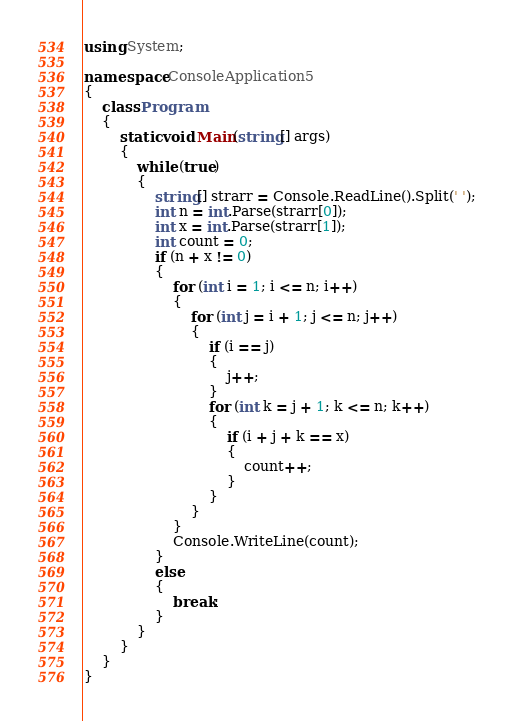Convert code to text. <code><loc_0><loc_0><loc_500><loc_500><_C#_>using System;

namespace ConsoleApplication5
{
    class Program
    {
        static void Main(string[] args)
        {
            while (true)
            {
                string[] strarr = Console.ReadLine().Split(' ');
                int n = int.Parse(strarr[0]);
                int x = int.Parse(strarr[1]);
                int count = 0;
                if (n + x != 0)
                {
                    for (int i = 1; i <= n; i++)
                    {
                        for (int j = i + 1; j <= n; j++)
                        {
                            if (i == j)
                            {
                                j++;
                            }
                            for (int k = j + 1; k <= n; k++)
                            {
                                if (i + j + k == x)
                                {
                                    count++;
                                }
                            }
                        }
                    }
                    Console.WriteLine(count);
                }
                else
                {
                    break;
                }
            }
        }
    }
}</code> 